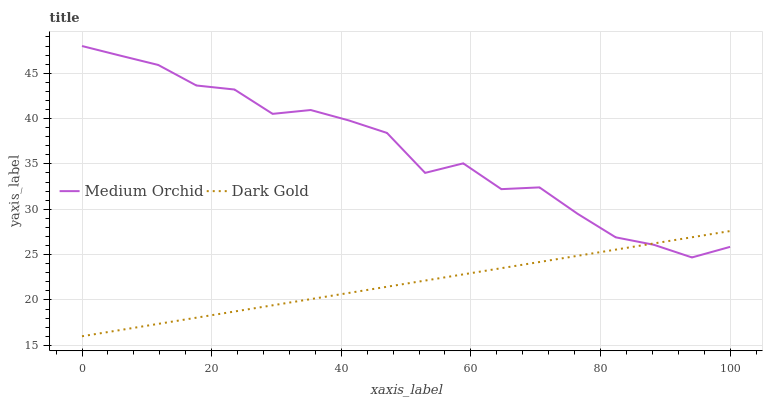Does Dark Gold have the minimum area under the curve?
Answer yes or no. Yes. Does Medium Orchid have the maximum area under the curve?
Answer yes or no. Yes. Does Dark Gold have the maximum area under the curve?
Answer yes or no. No. Is Dark Gold the smoothest?
Answer yes or no. Yes. Is Medium Orchid the roughest?
Answer yes or no. Yes. Is Dark Gold the roughest?
Answer yes or no. No. Does Dark Gold have the lowest value?
Answer yes or no. Yes. Does Medium Orchid have the highest value?
Answer yes or no. Yes. Does Dark Gold have the highest value?
Answer yes or no. No. Does Medium Orchid intersect Dark Gold?
Answer yes or no. Yes. Is Medium Orchid less than Dark Gold?
Answer yes or no. No. Is Medium Orchid greater than Dark Gold?
Answer yes or no. No. 